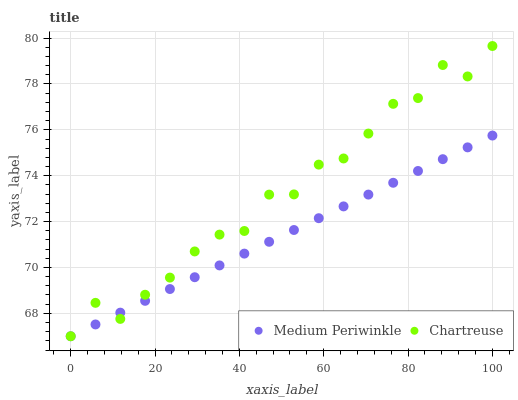Does Medium Periwinkle have the minimum area under the curve?
Answer yes or no. Yes. Does Chartreuse have the maximum area under the curve?
Answer yes or no. Yes. Does Medium Periwinkle have the maximum area under the curve?
Answer yes or no. No. Is Medium Periwinkle the smoothest?
Answer yes or no. Yes. Is Chartreuse the roughest?
Answer yes or no. Yes. Is Medium Periwinkle the roughest?
Answer yes or no. No. Does Chartreuse have the lowest value?
Answer yes or no. Yes. Does Chartreuse have the highest value?
Answer yes or no. Yes. Does Medium Periwinkle have the highest value?
Answer yes or no. No. Does Chartreuse intersect Medium Periwinkle?
Answer yes or no. Yes. Is Chartreuse less than Medium Periwinkle?
Answer yes or no. No. Is Chartreuse greater than Medium Periwinkle?
Answer yes or no. No. 